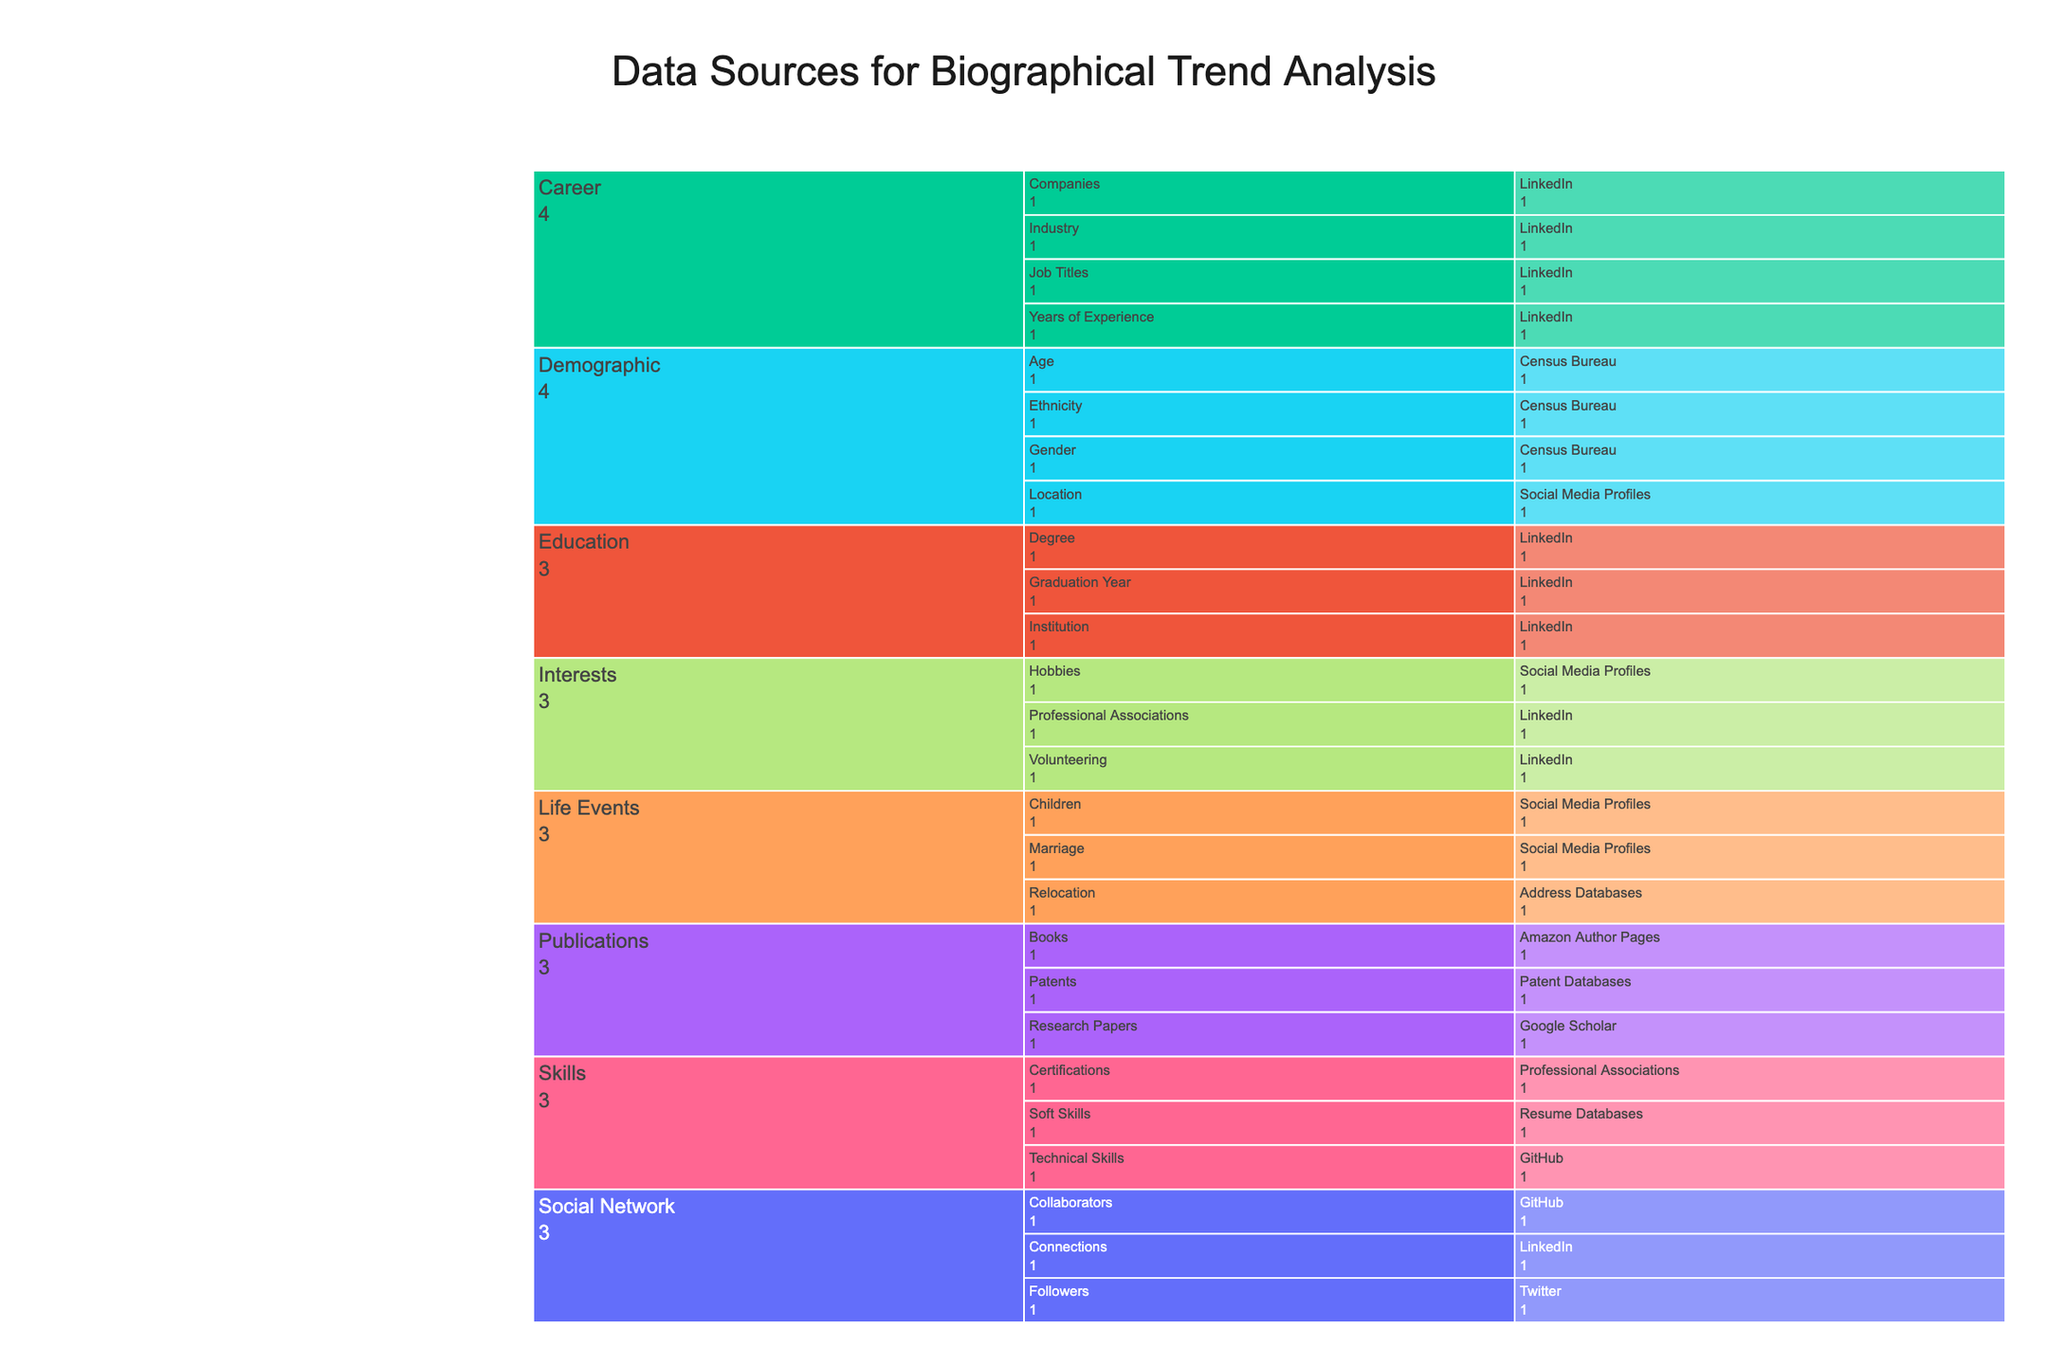Where can demographic data be sourced according to the figure? The "Demographic" category in the chart includes subtypes like Age, Gender, Ethnicity, and Location. Observing the third layer of the chart under each subtype, the source for all demographic data is shown to be the Census Bureau for Age, Gender, and Ethnicity, and Social Media Profiles for Location.
Answer: Census Bureau, Social Media Profiles Which data source contributes to the most subtypes under the "Career" category? In the chart, the "Career" category includes subtypes such as Job Titles, Companies, Industry, and Years of Experience. Observing the third layer of the chart under the "Career" category, LinkedIn is marked as the source for all these subtypes.
Answer: LinkedIn How many subtypes are there under the "Publications" category? The icicle chart displays subtypes "Research Papers", "Books", and "Patents" under the "Publications" category. Counting these, there are 3 subtypes.
Answer: 3 Which source is shared by both "Skills" and "Social Network" categories? Observing the chart, GitHub is shown as a source under the "Technical Skills" subtype in the "Skills" category and also under the "Collaborators" subtype in the "Social Network" category.
Answer: GitHub Which category has the most data sources, and how many are there? To determine this, count the sources listed under each main category (outer layer). "Demographic" has 2 sources ("Census Bureau" and "Social Media Profiles"), "Education" has 1 source ("LinkedIn"), "Career" has 1 source ("LinkedIn"), "Skills" has 3 sources ("GitHub", "Resume Databases", "Professional Associations"), "Life Events" has 3 sources ("Social Media Profiles", "Address Databases"), "Interests" has 3 sources ("Social Media Profiles", "LinkedIn"), "Publications" has 3 sources ("Google Scholar", "Amazon Author Pages", "Patent Databases"), and "Social Network" has 3 sources ("LinkedIn", "Twitter", "GitHub"). Checking these counts, several categories have the same highest number of data sources, which is 3.
Answer: 3 (Skills, Life Events, Interests, Publications, Social Network) Which source is specifically used for tracking certifications? The chart shows "Certifications" under the "Skills" category, and the source listed is "Professional Associations".
Answer: Professional Associations How many subtypes are tracked via LinkedIn? Examining the chart, LinkedIn is a source under the categories "Education", "Career", "Interests", and "Social Network". Counting subtypes under these where LinkedIn is the source (5 subtypes from "Career", 3 from "Education", 2 from "Interests", and "Connections" from "Social Network"), LinkedIn tracks 11 subtypes in total.
Answer: 11 Which category is partially sourced from resume databases? By observing the third layer of the chart, "Skills" have subtypes listed under it, and one of the sources for "Soft Skills" within the "Skills" category is "Resume Databases".
Answer: Skills 